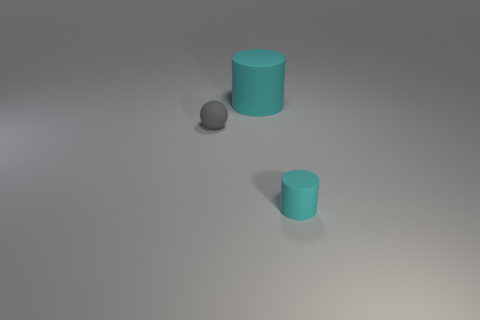Add 3 tiny things. How many objects exist? 6 Subtract all cylinders. How many objects are left? 1 Subtract 0 red spheres. How many objects are left? 3 Subtract all gray balls. Subtract all tiny gray rubber things. How many objects are left? 1 Add 3 tiny rubber balls. How many tiny rubber balls are left? 4 Add 2 tiny things. How many tiny things exist? 4 